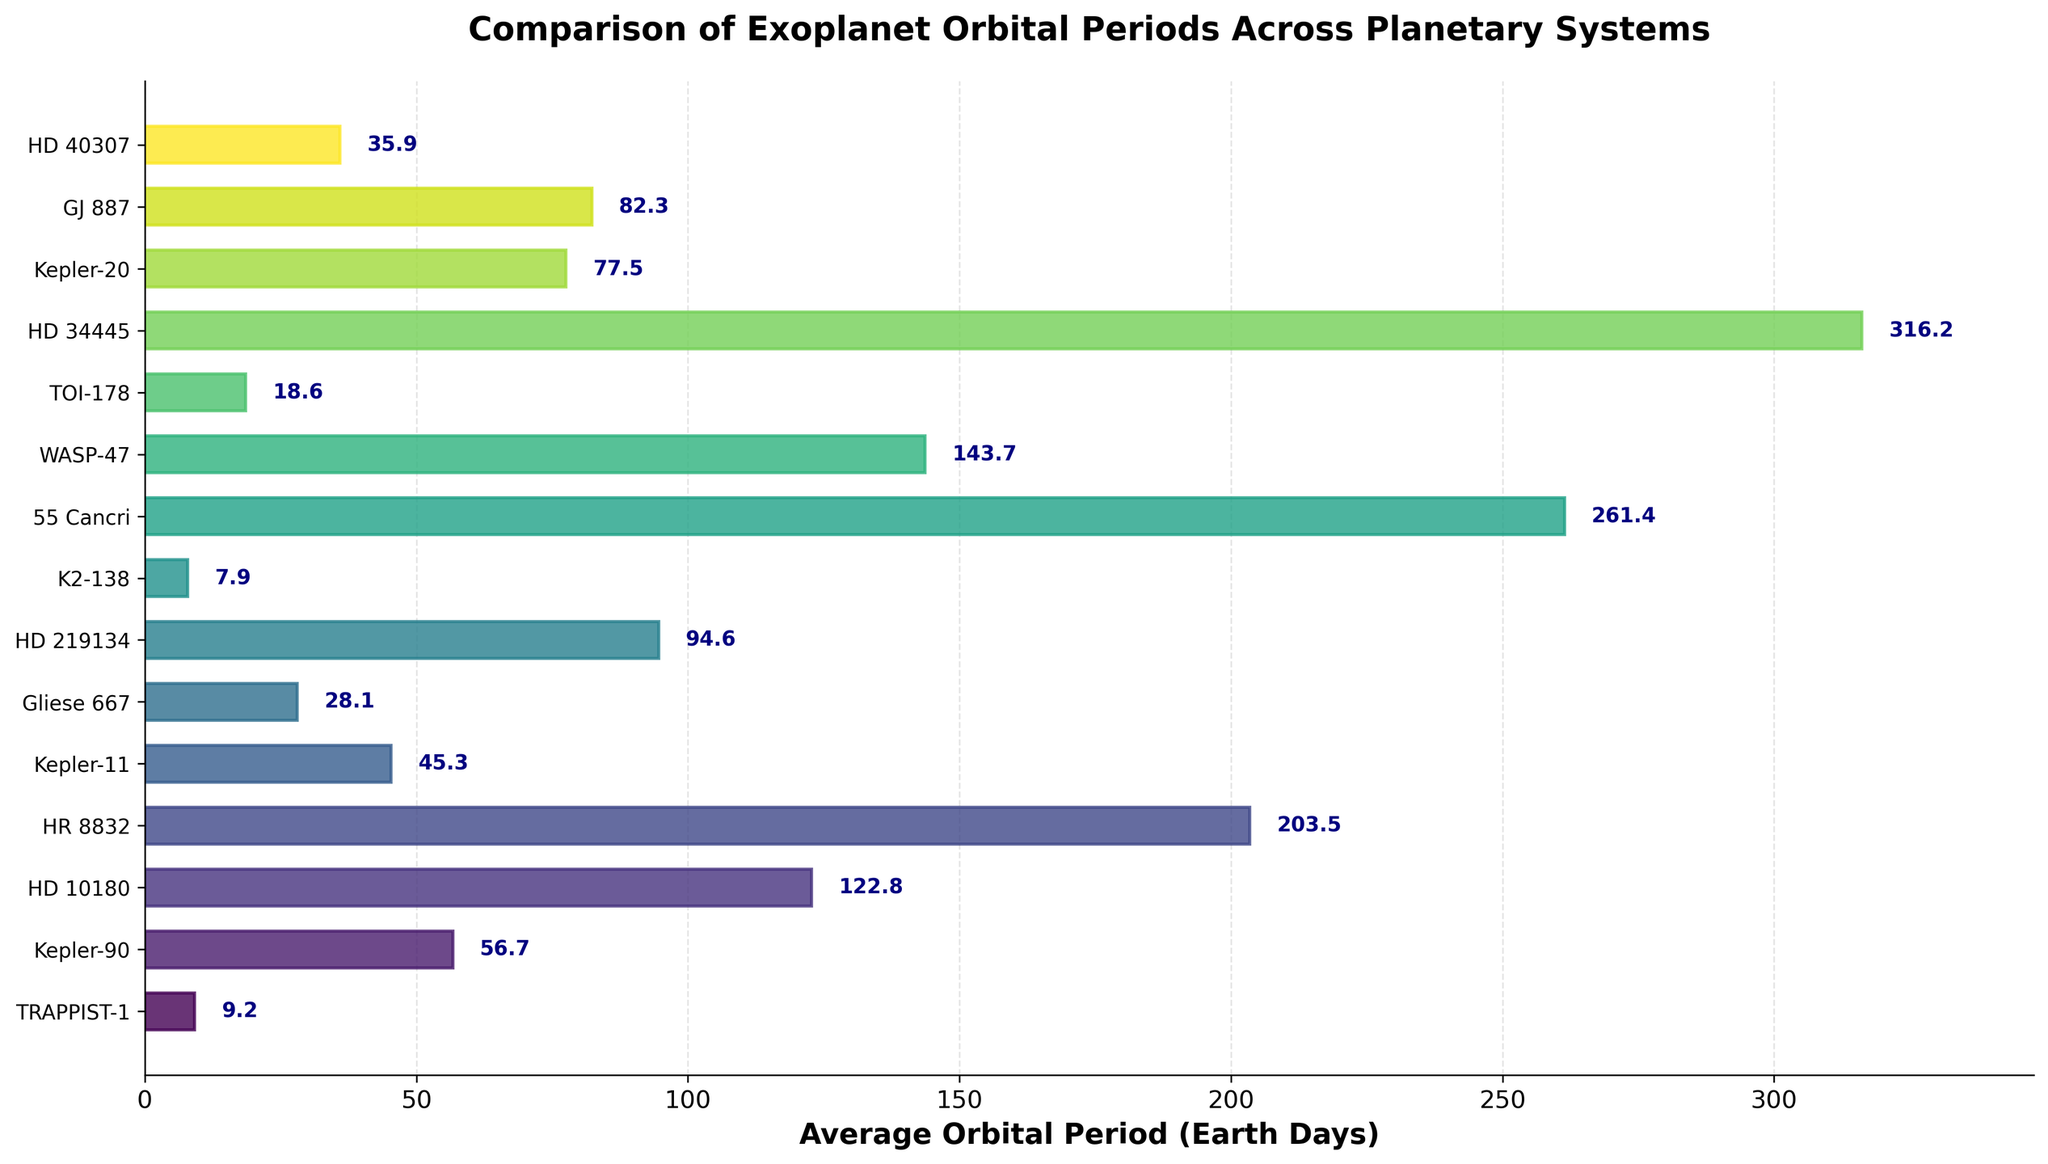Which planetary system has the shortest average orbital period? Look at the bar chart and identify the bar with the smallest value on the x-axis. The shortest bar corresponds to the planetary system K2-138 with an average orbital period of 7.9 Earth days
Answer: K2-138 Which planetary system has the longest average orbital period? Identify the bar that extends the furthest to the right on the x-axis. The longest bar corresponds to the HD 34445 planetary system, with an average orbital period of 316.2 Earth days
Answer: HD 34445 What is the difference in orbital periods between TRAPPIST-1 and Kepler-11? Subtract the average orbital period of TRAPPIST-1 (9.2 Earth days) from that of Kepler-11 (45.3 Earth days). Thus, 45.3 - 9.2 = 36.1 Earth days
Answer: 36.1 Which planetary system has a longer average orbital period: Gliese 667 or HD 40307? Compare the lengths of their respective bars. Gliese 667 has an average orbital period of 28.1 Earth days, while HD 40307 has an average orbital period of 35.9 Earth days. HD 40307 is longer
Answer: HD 40307 What is the average orbital period of the top 3 systems with the longest periods? Identify the top 3 systems with the longest periods: HD 34445 (316.2), 55 Cancri (261.4), and WASP-47 (143.7). Calculate the average: (316.2 + 261.4 + 143.7) / 3 = 240.4 Earth days
Answer: 240.4 How many planetary systems have average orbital periods less than 50 Earth days? Count the number of bars that extend to less than 50 on the x-axis. These are TRAPPIST-1 (9.2), K2-138 (7.9), TOI-178 (18.6), Gliese 667 (28.1), and HD 40307 (35.9), totaling 5 systems.
Answer: 5 What is the combined orbital period of Kepler-20 and GJ 887? Add the average orbital periods of Kepler-20 (77.5) and GJ 887 (82.3). So, 77.5 + 82.3 = 159.8 Earth days
Answer: 159.8 What is the median average orbital period among all the planetary systems? List the orbital periods in ascending order and identify the middle value. Middle values: 7.9, 9.2, 18.6, 28.1, 35.9, 45.3, 56.7, 77.5, 82.3, 94.6, 122.8, 143.7, 203.5, 261.4, 316.2. The middle value (8th value) is 77.5
Answer: 77.5 Which planetary systems have an average orbital period between 50 and 150 Earth days? Identify the bars whose lengths lie within 50 to 150 on the x-axis: Kepler-90 (56.7), HD 219134 (94.6), Kepler-20 (77.5), GJ 887 (82.3), Kepler-11 (45.3), and WASP-47 (143.7)
Answer: Kepler-90, HD 219134, Kepler-20, GJ 887, WASP-47 